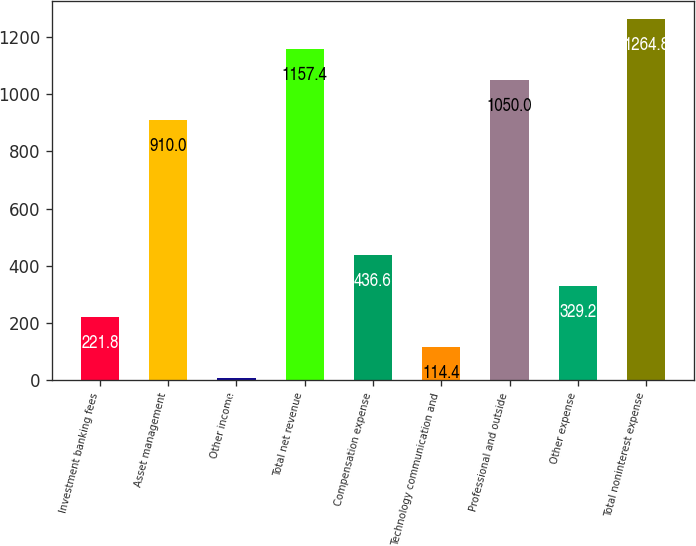<chart> <loc_0><loc_0><loc_500><loc_500><bar_chart><fcel>Investment banking fees<fcel>Asset management<fcel>Other income<fcel>Total net revenue<fcel>Compensation expense<fcel>Technology communication and<fcel>Professional and outside<fcel>Other expense<fcel>Total noninterest expense<nl><fcel>221.8<fcel>910<fcel>7<fcel>1157.4<fcel>436.6<fcel>114.4<fcel>1050<fcel>329.2<fcel>1264.8<nl></chart> 